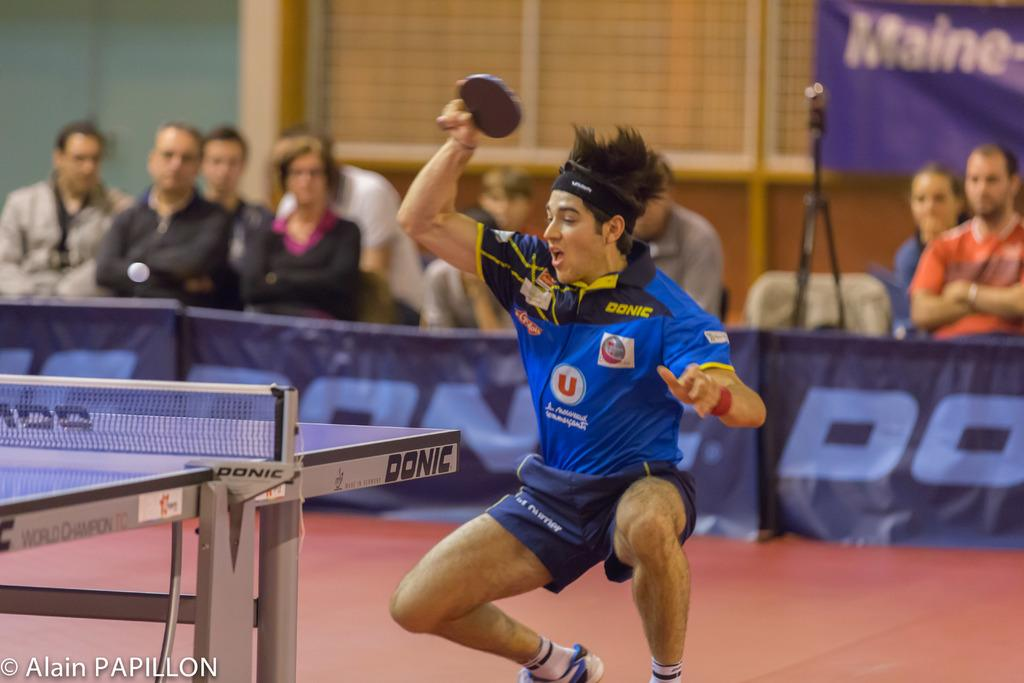What is located on the left side of the image? There is a table on the left side of the image. Who is the main subject in the center of the image? There is a man in the center of the image. What is the man wearing? The man is wearing a blue t-shirt. What can be seen in the background of the image? There is a wall, a banner, a camera, and people sitting on chairs in the background of the image. What type of feast is being prepared on the table in the image? There is no feast being prepared on the table in the image; it is a man standing in the center of the image. What invention is the man holding in his hand in the image? The man is not holding any invention in his hand in the image; he is simply standing with his arms at his sides. 